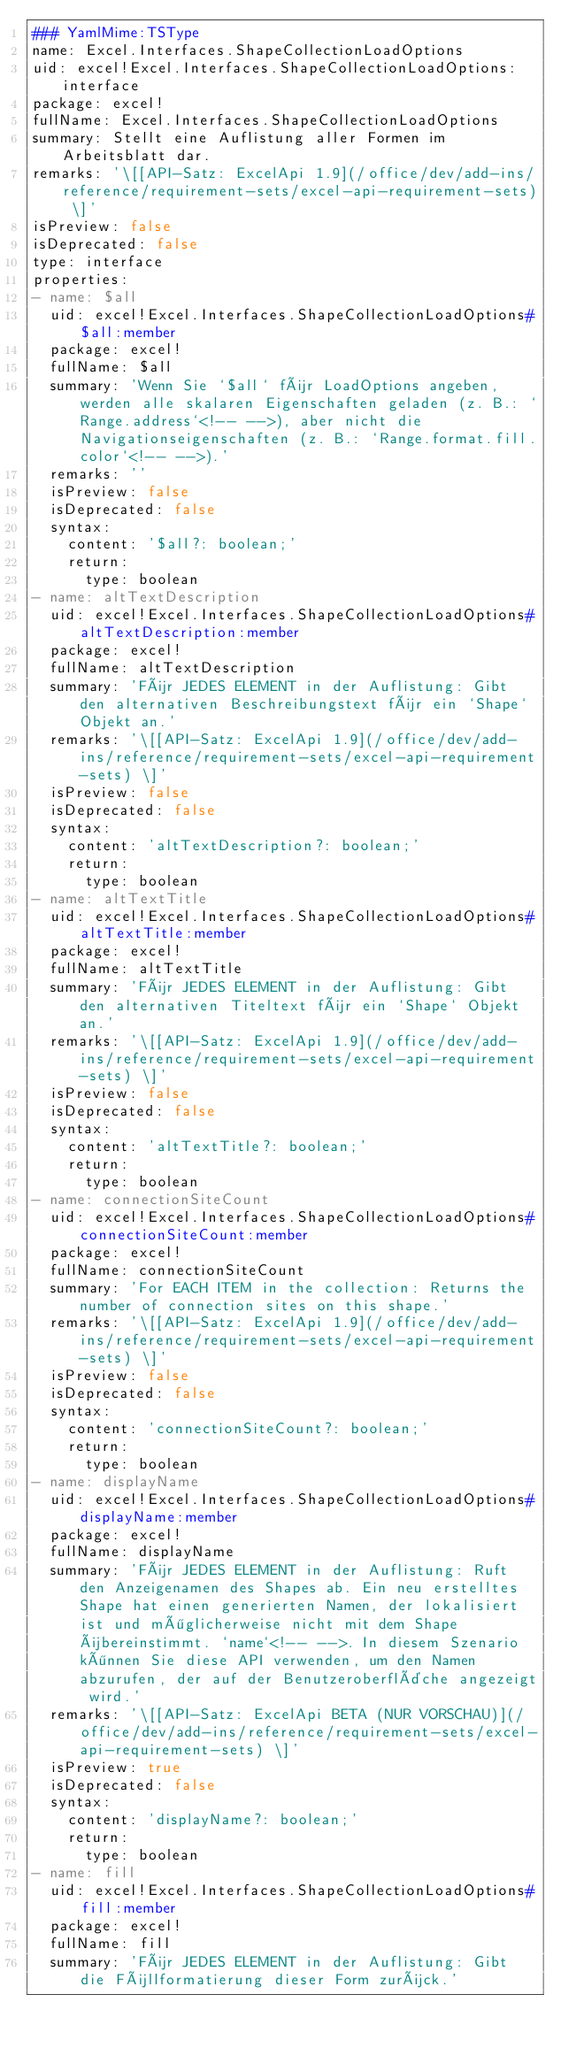<code> <loc_0><loc_0><loc_500><loc_500><_YAML_>### YamlMime:TSType
name: Excel.Interfaces.ShapeCollectionLoadOptions
uid: excel!Excel.Interfaces.ShapeCollectionLoadOptions:interface
package: excel!
fullName: Excel.Interfaces.ShapeCollectionLoadOptions
summary: Stellt eine Auflistung aller Formen im Arbeitsblatt dar.
remarks: '\[[API-Satz: ExcelApi 1.9](/office/dev/add-ins/reference/requirement-sets/excel-api-requirement-sets) \]'
isPreview: false
isDeprecated: false
type: interface
properties:
- name: $all
  uid: excel!Excel.Interfaces.ShapeCollectionLoadOptions#$all:member
  package: excel!
  fullName: $all
  summary: 'Wenn Sie `$all` für LoadOptions angeben, werden alle skalaren Eigenschaften geladen (z. B.: `Range.address`<!-- -->), aber nicht die Navigationseigenschaften (z. B.: `Range.format.fill.color`<!-- -->).'
  remarks: ''
  isPreview: false
  isDeprecated: false
  syntax:
    content: '$all?: boolean;'
    return:
      type: boolean
- name: altTextDescription
  uid: excel!Excel.Interfaces.ShapeCollectionLoadOptions#altTextDescription:member
  package: excel!
  fullName: altTextDescription
  summary: 'Für JEDES ELEMENT in der Auflistung: Gibt den alternativen Beschreibungstext für ein `Shape` Objekt an.'
  remarks: '\[[API-Satz: ExcelApi 1.9](/office/dev/add-ins/reference/requirement-sets/excel-api-requirement-sets) \]'
  isPreview: false
  isDeprecated: false
  syntax:
    content: 'altTextDescription?: boolean;'
    return:
      type: boolean
- name: altTextTitle
  uid: excel!Excel.Interfaces.ShapeCollectionLoadOptions#altTextTitle:member
  package: excel!
  fullName: altTextTitle
  summary: 'Für JEDES ELEMENT in der Auflistung: Gibt den alternativen Titeltext für ein `Shape` Objekt an.'
  remarks: '\[[API-Satz: ExcelApi 1.9](/office/dev/add-ins/reference/requirement-sets/excel-api-requirement-sets) \]'
  isPreview: false
  isDeprecated: false
  syntax:
    content: 'altTextTitle?: boolean;'
    return:
      type: boolean
- name: connectionSiteCount
  uid: excel!Excel.Interfaces.ShapeCollectionLoadOptions#connectionSiteCount:member
  package: excel!
  fullName: connectionSiteCount
  summary: 'For EACH ITEM in the collection: Returns the number of connection sites on this shape.'
  remarks: '\[[API-Satz: ExcelApi 1.9](/office/dev/add-ins/reference/requirement-sets/excel-api-requirement-sets) \]'
  isPreview: false
  isDeprecated: false
  syntax:
    content: 'connectionSiteCount?: boolean;'
    return:
      type: boolean
- name: displayName
  uid: excel!Excel.Interfaces.ShapeCollectionLoadOptions#displayName:member
  package: excel!
  fullName: displayName
  summary: 'Für JEDES ELEMENT in der Auflistung: Ruft den Anzeigenamen des Shapes ab. Ein neu erstelltes Shape hat einen generierten Namen, der lokalisiert ist und möglicherweise nicht mit dem Shape übereinstimmt. `name`<!-- -->. In diesem Szenario können Sie diese API verwenden, um den Namen abzurufen, der auf der Benutzeroberfläche angezeigt wird.'
  remarks: '\[[API-Satz: ExcelApi BETA (NUR VORSCHAU)](/office/dev/add-ins/reference/requirement-sets/excel-api-requirement-sets) \]'
  isPreview: true
  isDeprecated: false
  syntax:
    content: 'displayName?: boolean;'
    return:
      type: boolean
- name: fill
  uid: excel!Excel.Interfaces.ShapeCollectionLoadOptions#fill:member
  package: excel!
  fullName: fill
  summary: 'Für JEDES ELEMENT in der Auflistung: Gibt die Füllformatierung dieser Form zurück.'</code> 